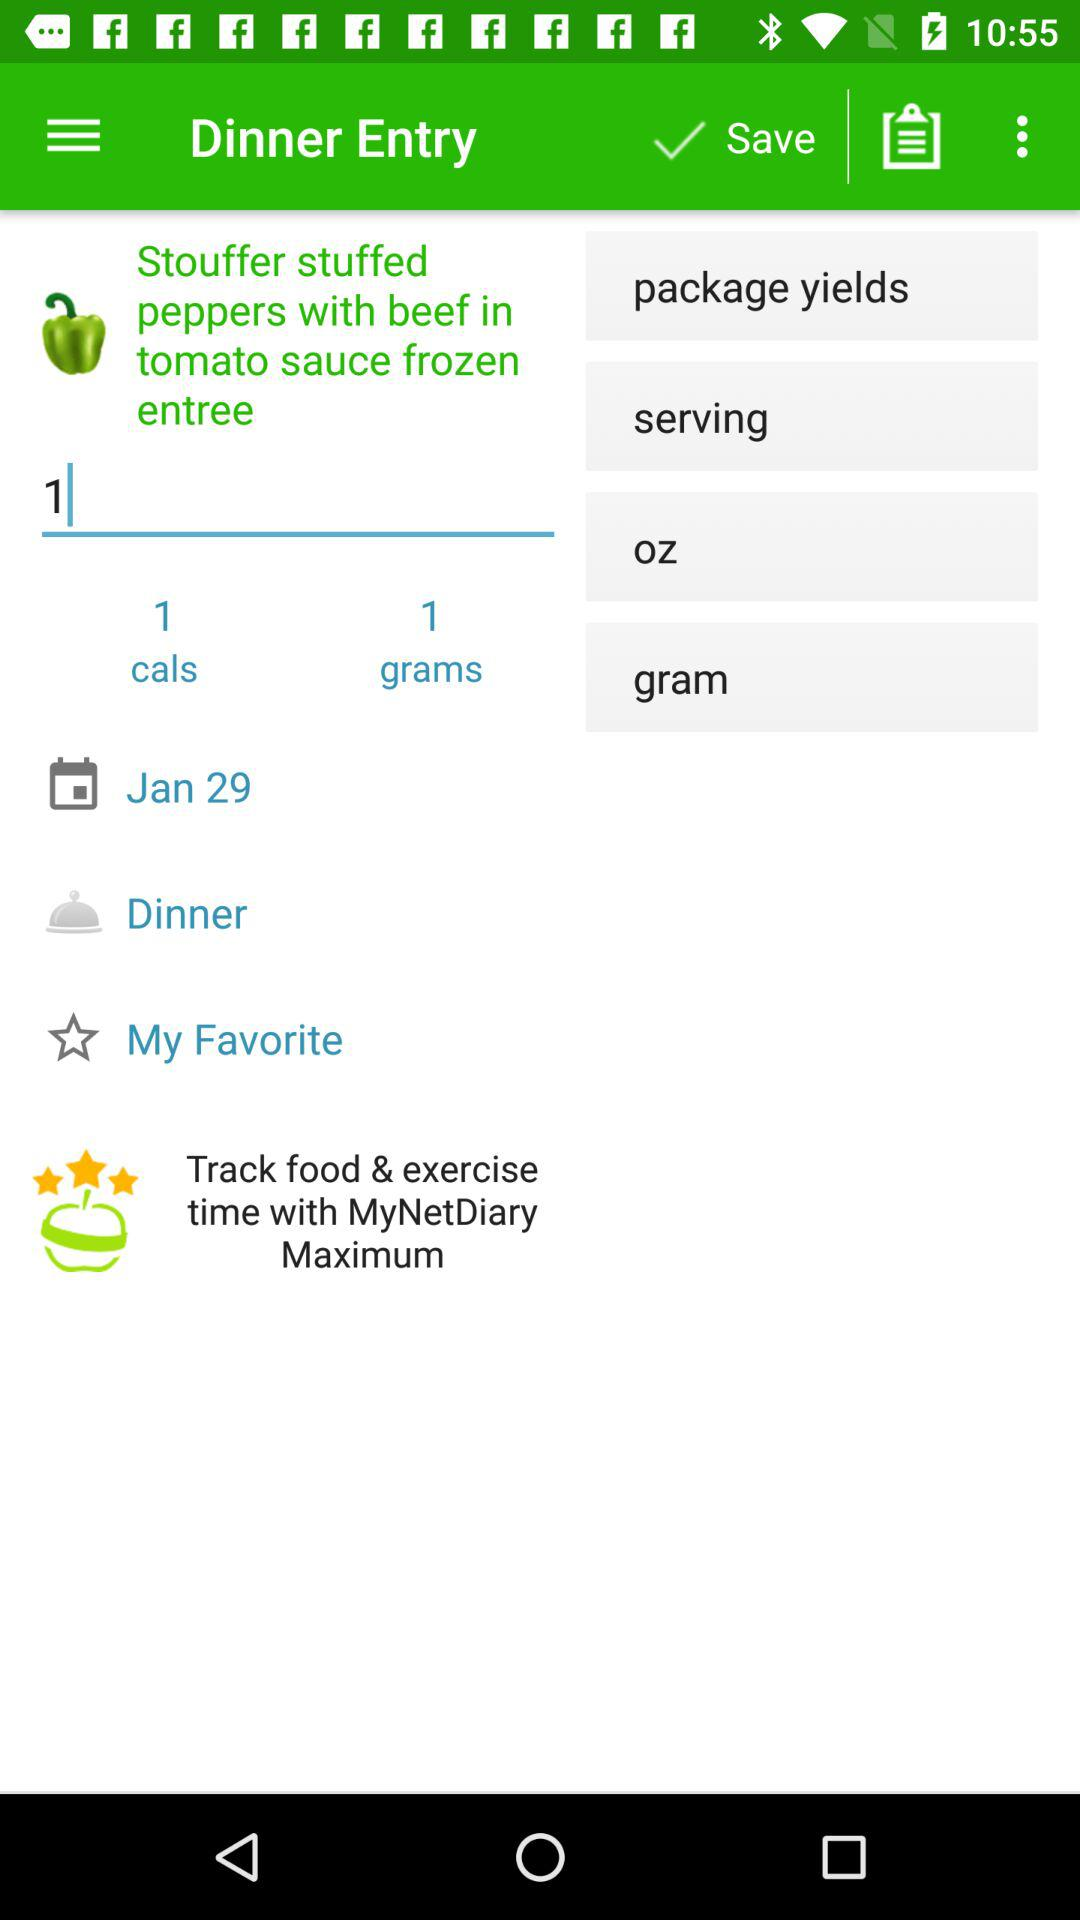For what date is dinner ordered? The date is January 29. 